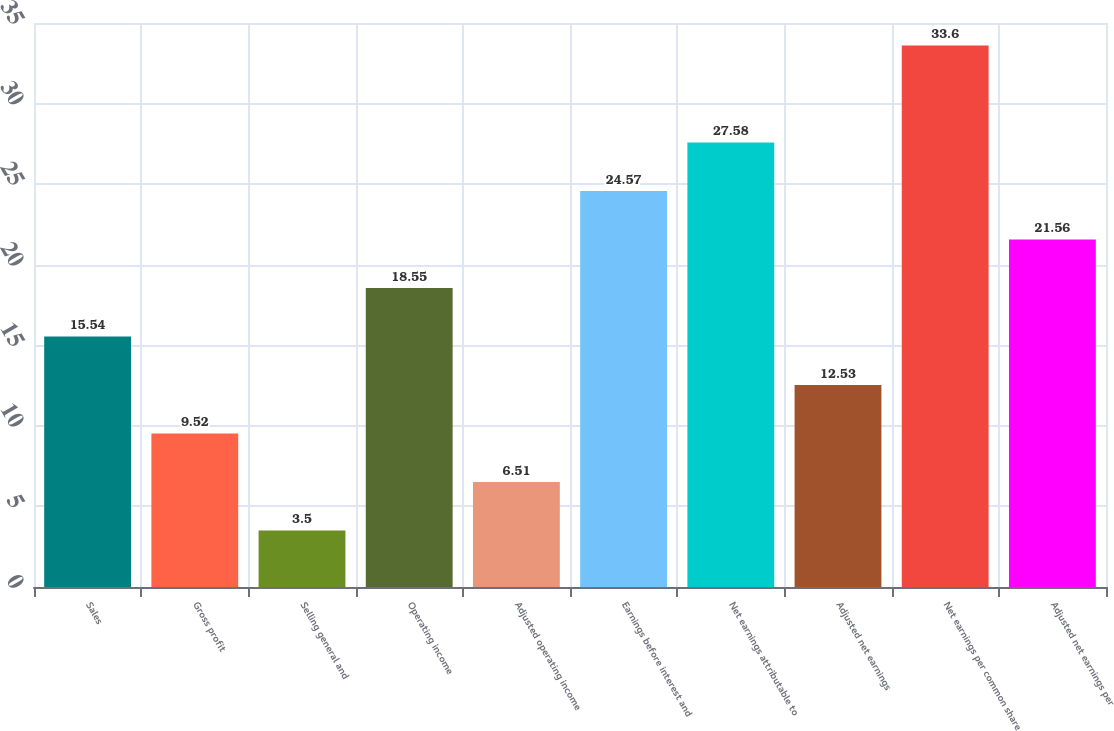Convert chart to OTSL. <chart><loc_0><loc_0><loc_500><loc_500><bar_chart><fcel>Sales<fcel>Gross profit<fcel>Selling general and<fcel>Operating income<fcel>Adjusted operating income<fcel>Earnings before interest and<fcel>Net earnings attributable to<fcel>Adjusted net earnings<fcel>Net earnings per common share<fcel>Adjusted net earnings per<nl><fcel>15.54<fcel>9.52<fcel>3.5<fcel>18.55<fcel>6.51<fcel>24.57<fcel>27.58<fcel>12.53<fcel>33.6<fcel>21.56<nl></chart> 